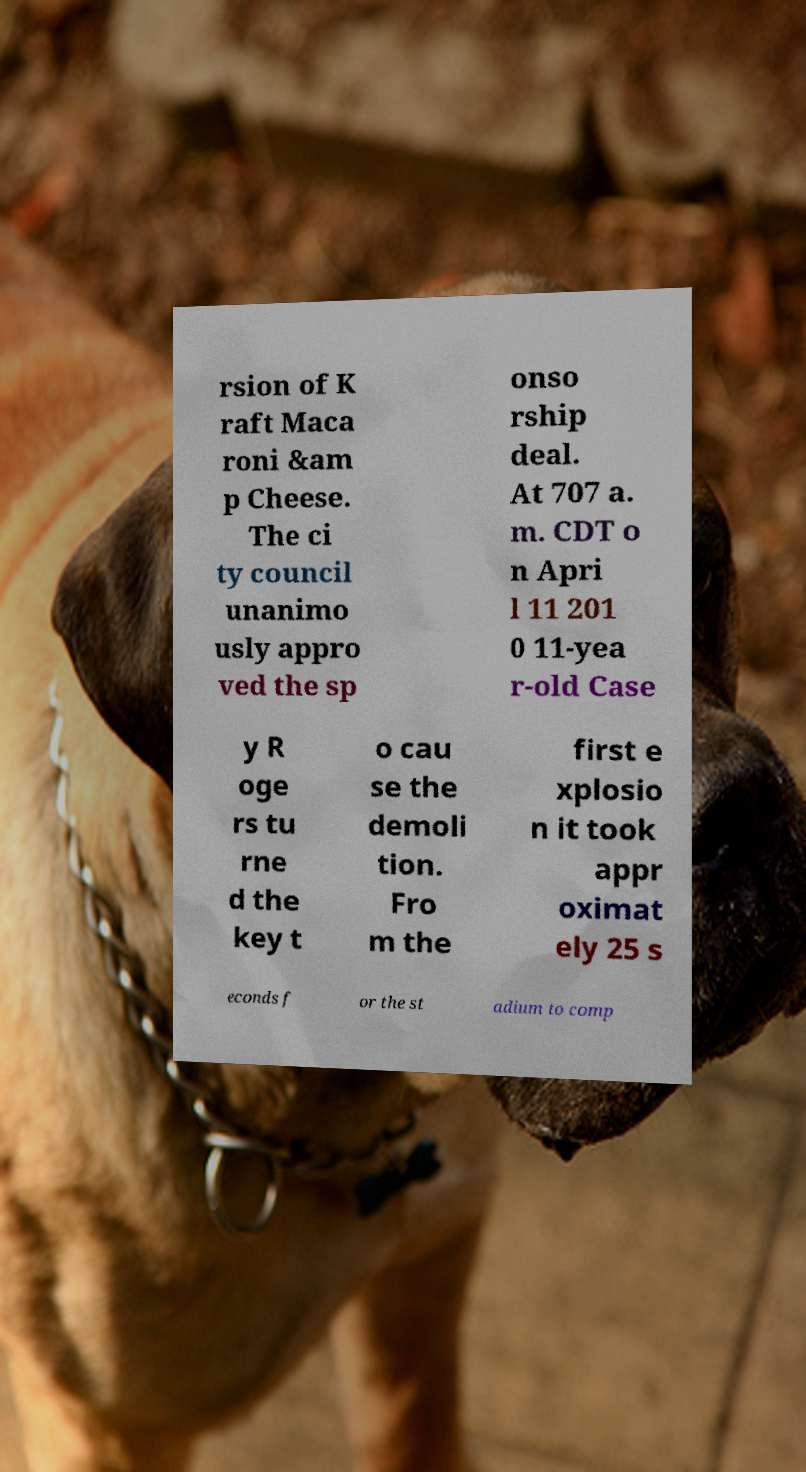Please read and relay the text visible in this image. What does it say? rsion of K raft Maca roni &am p Cheese. The ci ty council unanimo usly appro ved the sp onso rship deal. At 707 a. m. CDT o n Apri l 11 201 0 11-yea r-old Case y R oge rs tu rne d the key t o cau se the demoli tion. Fro m the first e xplosio n it took appr oximat ely 25 s econds f or the st adium to comp 